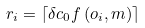Convert formula to latex. <formula><loc_0><loc_0><loc_500><loc_500>r _ { i } = \left \lceil \delta c _ { 0 } f \left ( o _ { i } , m \right ) \right \rceil</formula> 